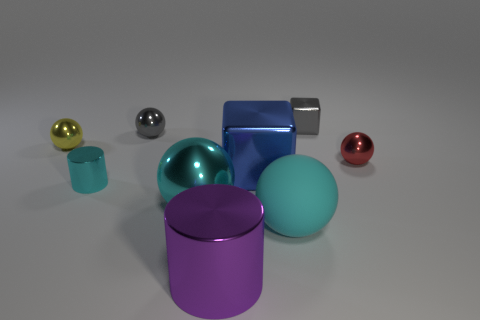Does the tiny metallic cylinder have the same color as the big sphere that is right of the large metal cylinder?
Provide a short and direct response. Yes. There is a metal sphere on the right side of the tiny gray thing that is behind the gray ball; what number of cubes are to the left of it?
Offer a very short reply. 2. There is a cyan metal sphere; are there any cyan matte objects left of it?
Your answer should be compact. No. Are there any other things of the same color as the big matte object?
Offer a terse response. Yes. What number of cubes are either cyan rubber things or purple metal objects?
Offer a very short reply. 0. How many metal things are both in front of the blue shiny object and behind the gray shiny ball?
Your response must be concise. 0. Are there the same number of tiny gray balls on the right side of the rubber thing and things right of the large purple metallic object?
Provide a succinct answer. No. There is a small gray metallic object right of the big cyan rubber sphere; is it the same shape as the blue thing?
Your response must be concise. Yes. There is a big cyan metallic object in front of the small shiny thing that is on the left side of the tiny metallic thing in front of the small red shiny object; what shape is it?
Your response must be concise. Sphere. What shape is the big shiny thing that is the same color as the large rubber sphere?
Give a very brief answer. Sphere. 